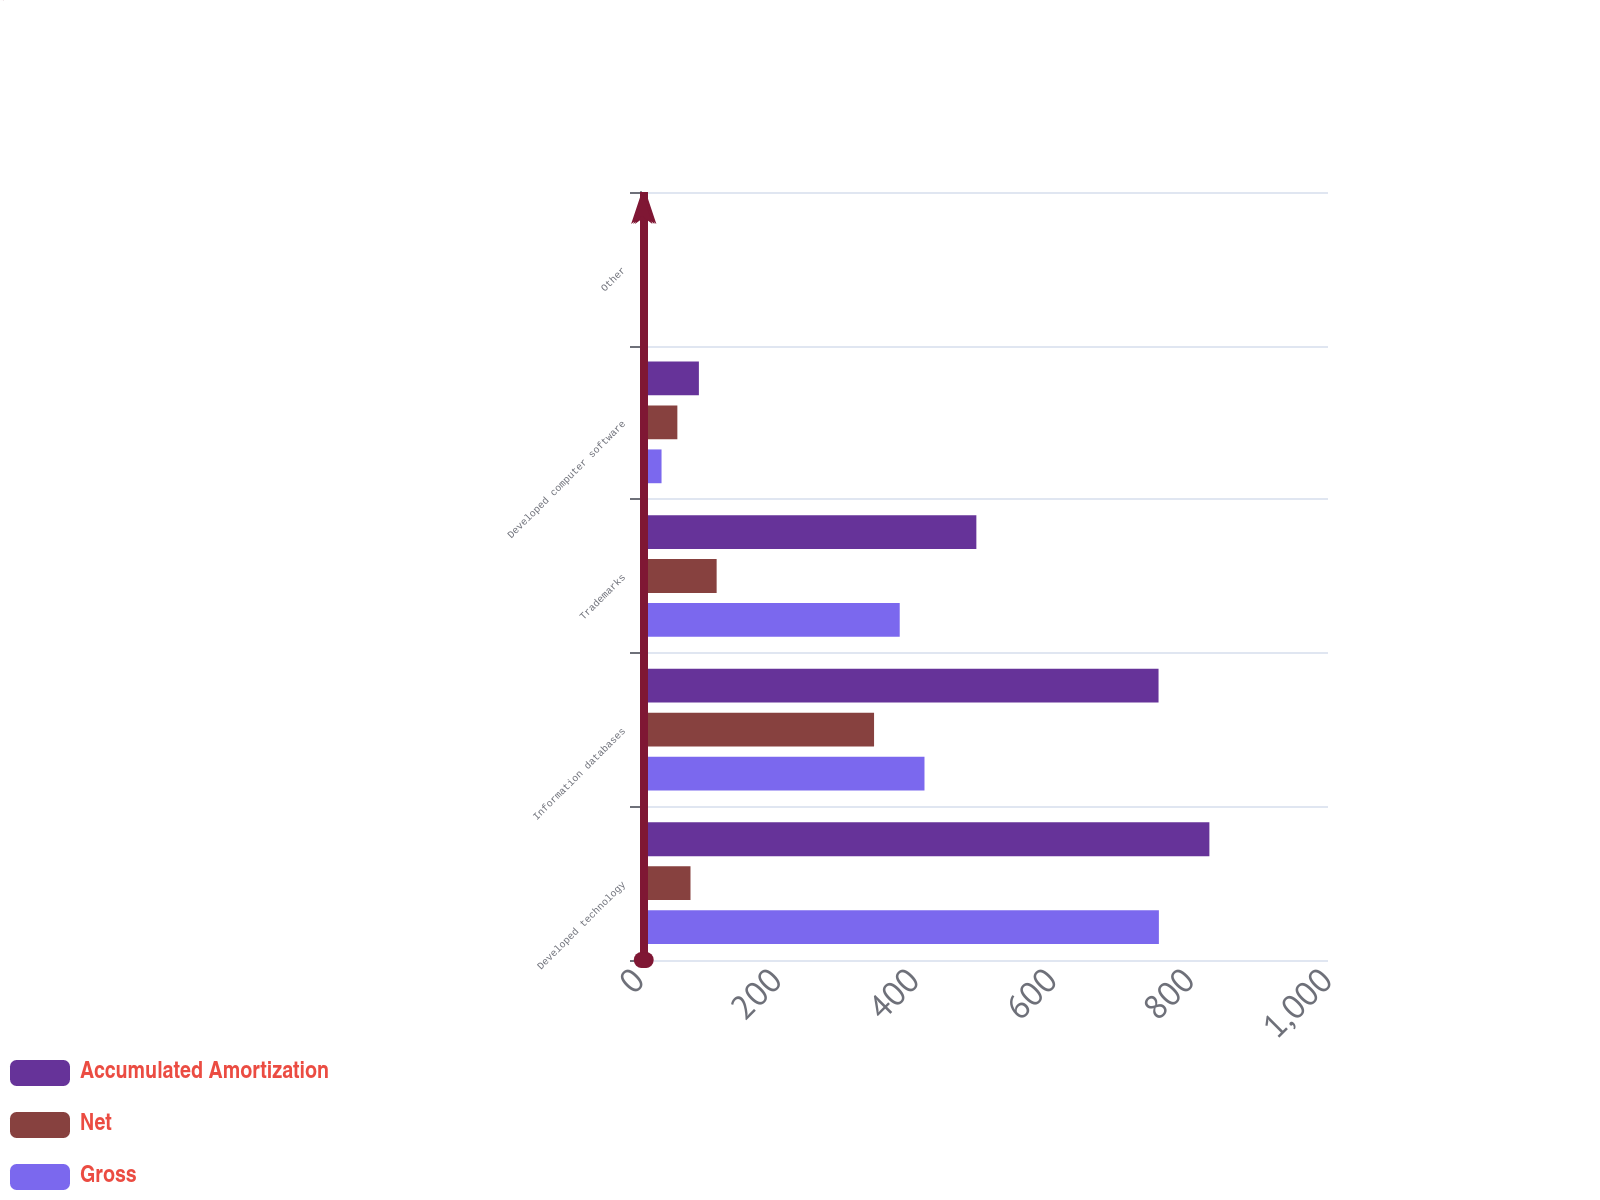Convert chart to OTSL. <chart><loc_0><loc_0><loc_500><loc_500><stacked_bar_chart><ecel><fcel>Developed technology<fcel>Information databases<fcel>Trademarks<fcel>Developed computer software<fcel>Other<nl><fcel>Accumulated Amortization<fcel>827.6<fcel>753.7<fcel>488.9<fcel>85.6<fcel>8.3<nl><fcel>Net<fcel>73.4<fcel>340.2<fcel>111.4<fcel>54.3<fcel>5.7<nl><fcel>Gross<fcel>754.2<fcel>413.5<fcel>377.5<fcel>31.3<fcel>2.6<nl></chart> 